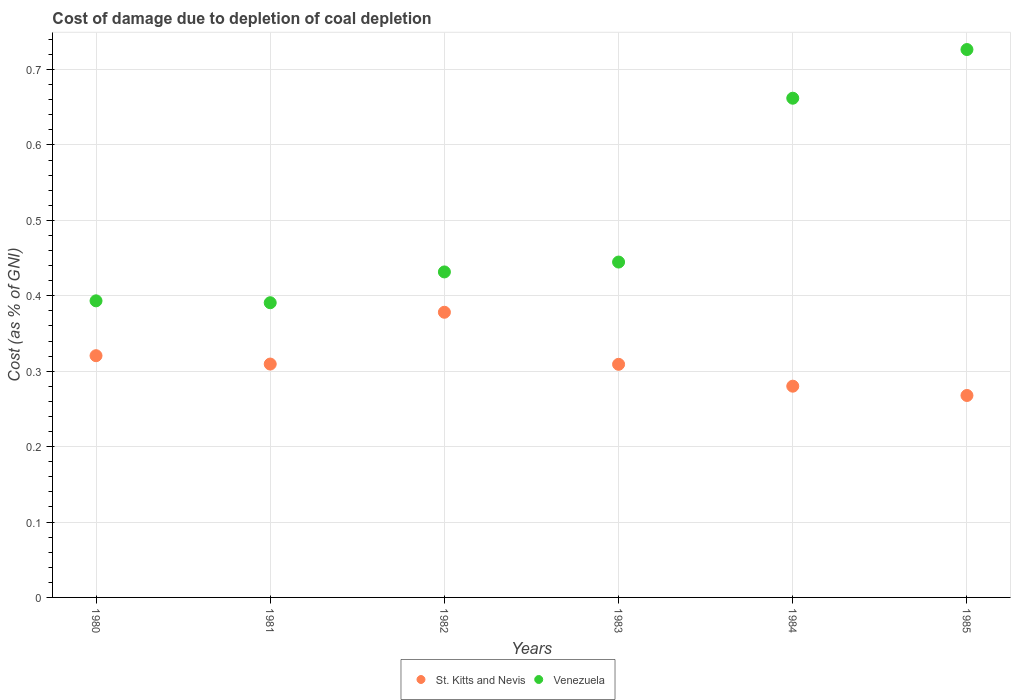What is the cost of damage caused due to coal depletion in St. Kitts and Nevis in 1981?
Your response must be concise. 0.31. Across all years, what is the maximum cost of damage caused due to coal depletion in St. Kitts and Nevis?
Make the answer very short. 0.38. Across all years, what is the minimum cost of damage caused due to coal depletion in Venezuela?
Provide a succinct answer. 0.39. In which year was the cost of damage caused due to coal depletion in St. Kitts and Nevis minimum?
Your answer should be very brief. 1985. What is the total cost of damage caused due to coal depletion in St. Kitts and Nevis in the graph?
Your answer should be compact. 1.87. What is the difference between the cost of damage caused due to coal depletion in St. Kitts and Nevis in 1981 and that in 1984?
Ensure brevity in your answer.  0.03. What is the difference between the cost of damage caused due to coal depletion in St. Kitts and Nevis in 1984 and the cost of damage caused due to coal depletion in Venezuela in 1982?
Keep it short and to the point. -0.15. What is the average cost of damage caused due to coal depletion in Venezuela per year?
Offer a very short reply. 0.51. In the year 1984, what is the difference between the cost of damage caused due to coal depletion in St. Kitts and Nevis and cost of damage caused due to coal depletion in Venezuela?
Keep it short and to the point. -0.38. What is the ratio of the cost of damage caused due to coal depletion in Venezuela in 1983 to that in 1985?
Provide a succinct answer. 0.61. What is the difference between the highest and the second highest cost of damage caused due to coal depletion in St. Kitts and Nevis?
Make the answer very short. 0.06. What is the difference between the highest and the lowest cost of damage caused due to coal depletion in St. Kitts and Nevis?
Your answer should be very brief. 0.11. In how many years, is the cost of damage caused due to coal depletion in St. Kitts and Nevis greater than the average cost of damage caused due to coal depletion in St. Kitts and Nevis taken over all years?
Provide a short and direct response. 2. Does the cost of damage caused due to coal depletion in Venezuela monotonically increase over the years?
Your answer should be very brief. No. Is the cost of damage caused due to coal depletion in Venezuela strictly greater than the cost of damage caused due to coal depletion in St. Kitts and Nevis over the years?
Your answer should be very brief. Yes. Is the cost of damage caused due to coal depletion in Venezuela strictly less than the cost of damage caused due to coal depletion in St. Kitts and Nevis over the years?
Make the answer very short. No. How many dotlines are there?
Ensure brevity in your answer.  2. How many years are there in the graph?
Offer a terse response. 6. Does the graph contain any zero values?
Keep it short and to the point. No. Does the graph contain grids?
Keep it short and to the point. Yes. Where does the legend appear in the graph?
Your response must be concise. Bottom center. How many legend labels are there?
Provide a short and direct response. 2. How are the legend labels stacked?
Your answer should be compact. Horizontal. What is the title of the graph?
Provide a succinct answer. Cost of damage due to depletion of coal depletion. Does "Cabo Verde" appear as one of the legend labels in the graph?
Your answer should be very brief. No. What is the label or title of the X-axis?
Your response must be concise. Years. What is the label or title of the Y-axis?
Offer a terse response. Cost (as % of GNI). What is the Cost (as % of GNI) in St. Kitts and Nevis in 1980?
Make the answer very short. 0.32. What is the Cost (as % of GNI) in Venezuela in 1980?
Your answer should be very brief. 0.39. What is the Cost (as % of GNI) in St. Kitts and Nevis in 1981?
Give a very brief answer. 0.31. What is the Cost (as % of GNI) of Venezuela in 1981?
Keep it short and to the point. 0.39. What is the Cost (as % of GNI) in St. Kitts and Nevis in 1982?
Make the answer very short. 0.38. What is the Cost (as % of GNI) in Venezuela in 1982?
Your answer should be very brief. 0.43. What is the Cost (as % of GNI) of St. Kitts and Nevis in 1983?
Provide a short and direct response. 0.31. What is the Cost (as % of GNI) of Venezuela in 1983?
Keep it short and to the point. 0.44. What is the Cost (as % of GNI) in St. Kitts and Nevis in 1984?
Ensure brevity in your answer.  0.28. What is the Cost (as % of GNI) of Venezuela in 1984?
Make the answer very short. 0.66. What is the Cost (as % of GNI) of St. Kitts and Nevis in 1985?
Your answer should be compact. 0.27. What is the Cost (as % of GNI) of Venezuela in 1985?
Make the answer very short. 0.73. Across all years, what is the maximum Cost (as % of GNI) of St. Kitts and Nevis?
Make the answer very short. 0.38. Across all years, what is the maximum Cost (as % of GNI) of Venezuela?
Ensure brevity in your answer.  0.73. Across all years, what is the minimum Cost (as % of GNI) in St. Kitts and Nevis?
Keep it short and to the point. 0.27. Across all years, what is the minimum Cost (as % of GNI) in Venezuela?
Your answer should be very brief. 0.39. What is the total Cost (as % of GNI) of St. Kitts and Nevis in the graph?
Keep it short and to the point. 1.87. What is the total Cost (as % of GNI) in Venezuela in the graph?
Give a very brief answer. 3.05. What is the difference between the Cost (as % of GNI) in St. Kitts and Nevis in 1980 and that in 1981?
Provide a short and direct response. 0.01. What is the difference between the Cost (as % of GNI) of Venezuela in 1980 and that in 1981?
Keep it short and to the point. 0. What is the difference between the Cost (as % of GNI) of St. Kitts and Nevis in 1980 and that in 1982?
Your answer should be compact. -0.06. What is the difference between the Cost (as % of GNI) in Venezuela in 1980 and that in 1982?
Make the answer very short. -0.04. What is the difference between the Cost (as % of GNI) in St. Kitts and Nevis in 1980 and that in 1983?
Offer a terse response. 0.01. What is the difference between the Cost (as % of GNI) of Venezuela in 1980 and that in 1983?
Make the answer very short. -0.05. What is the difference between the Cost (as % of GNI) of St. Kitts and Nevis in 1980 and that in 1984?
Your response must be concise. 0.04. What is the difference between the Cost (as % of GNI) in Venezuela in 1980 and that in 1984?
Keep it short and to the point. -0.27. What is the difference between the Cost (as % of GNI) of St. Kitts and Nevis in 1980 and that in 1985?
Give a very brief answer. 0.05. What is the difference between the Cost (as % of GNI) in Venezuela in 1980 and that in 1985?
Your response must be concise. -0.33. What is the difference between the Cost (as % of GNI) in St. Kitts and Nevis in 1981 and that in 1982?
Provide a succinct answer. -0.07. What is the difference between the Cost (as % of GNI) of Venezuela in 1981 and that in 1982?
Give a very brief answer. -0.04. What is the difference between the Cost (as % of GNI) in St. Kitts and Nevis in 1981 and that in 1983?
Give a very brief answer. 0. What is the difference between the Cost (as % of GNI) in Venezuela in 1981 and that in 1983?
Make the answer very short. -0.05. What is the difference between the Cost (as % of GNI) of St. Kitts and Nevis in 1981 and that in 1984?
Make the answer very short. 0.03. What is the difference between the Cost (as % of GNI) of Venezuela in 1981 and that in 1984?
Offer a terse response. -0.27. What is the difference between the Cost (as % of GNI) of St. Kitts and Nevis in 1981 and that in 1985?
Make the answer very short. 0.04. What is the difference between the Cost (as % of GNI) of Venezuela in 1981 and that in 1985?
Your response must be concise. -0.34. What is the difference between the Cost (as % of GNI) in St. Kitts and Nevis in 1982 and that in 1983?
Offer a terse response. 0.07. What is the difference between the Cost (as % of GNI) in Venezuela in 1982 and that in 1983?
Your answer should be compact. -0.01. What is the difference between the Cost (as % of GNI) of St. Kitts and Nevis in 1982 and that in 1984?
Your answer should be very brief. 0.1. What is the difference between the Cost (as % of GNI) of Venezuela in 1982 and that in 1984?
Your answer should be very brief. -0.23. What is the difference between the Cost (as % of GNI) of St. Kitts and Nevis in 1982 and that in 1985?
Ensure brevity in your answer.  0.11. What is the difference between the Cost (as % of GNI) of Venezuela in 1982 and that in 1985?
Keep it short and to the point. -0.29. What is the difference between the Cost (as % of GNI) of St. Kitts and Nevis in 1983 and that in 1984?
Your answer should be compact. 0.03. What is the difference between the Cost (as % of GNI) of Venezuela in 1983 and that in 1984?
Ensure brevity in your answer.  -0.22. What is the difference between the Cost (as % of GNI) of St. Kitts and Nevis in 1983 and that in 1985?
Keep it short and to the point. 0.04. What is the difference between the Cost (as % of GNI) in Venezuela in 1983 and that in 1985?
Offer a terse response. -0.28. What is the difference between the Cost (as % of GNI) of St. Kitts and Nevis in 1984 and that in 1985?
Offer a terse response. 0.01. What is the difference between the Cost (as % of GNI) of Venezuela in 1984 and that in 1985?
Your answer should be compact. -0.06. What is the difference between the Cost (as % of GNI) in St. Kitts and Nevis in 1980 and the Cost (as % of GNI) in Venezuela in 1981?
Give a very brief answer. -0.07. What is the difference between the Cost (as % of GNI) of St. Kitts and Nevis in 1980 and the Cost (as % of GNI) of Venezuela in 1982?
Offer a very short reply. -0.11. What is the difference between the Cost (as % of GNI) of St. Kitts and Nevis in 1980 and the Cost (as % of GNI) of Venezuela in 1983?
Provide a succinct answer. -0.12. What is the difference between the Cost (as % of GNI) in St. Kitts and Nevis in 1980 and the Cost (as % of GNI) in Venezuela in 1984?
Your answer should be compact. -0.34. What is the difference between the Cost (as % of GNI) in St. Kitts and Nevis in 1980 and the Cost (as % of GNI) in Venezuela in 1985?
Your response must be concise. -0.41. What is the difference between the Cost (as % of GNI) in St. Kitts and Nevis in 1981 and the Cost (as % of GNI) in Venezuela in 1982?
Offer a terse response. -0.12. What is the difference between the Cost (as % of GNI) of St. Kitts and Nevis in 1981 and the Cost (as % of GNI) of Venezuela in 1983?
Provide a short and direct response. -0.14. What is the difference between the Cost (as % of GNI) of St. Kitts and Nevis in 1981 and the Cost (as % of GNI) of Venezuela in 1984?
Offer a terse response. -0.35. What is the difference between the Cost (as % of GNI) in St. Kitts and Nevis in 1981 and the Cost (as % of GNI) in Venezuela in 1985?
Your answer should be very brief. -0.42. What is the difference between the Cost (as % of GNI) in St. Kitts and Nevis in 1982 and the Cost (as % of GNI) in Venezuela in 1983?
Ensure brevity in your answer.  -0.07. What is the difference between the Cost (as % of GNI) of St. Kitts and Nevis in 1982 and the Cost (as % of GNI) of Venezuela in 1984?
Offer a terse response. -0.28. What is the difference between the Cost (as % of GNI) of St. Kitts and Nevis in 1982 and the Cost (as % of GNI) of Venezuela in 1985?
Ensure brevity in your answer.  -0.35. What is the difference between the Cost (as % of GNI) in St. Kitts and Nevis in 1983 and the Cost (as % of GNI) in Venezuela in 1984?
Provide a succinct answer. -0.35. What is the difference between the Cost (as % of GNI) of St. Kitts and Nevis in 1983 and the Cost (as % of GNI) of Venezuela in 1985?
Offer a terse response. -0.42. What is the difference between the Cost (as % of GNI) of St. Kitts and Nevis in 1984 and the Cost (as % of GNI) of Venezuela in 1985?
Offer a terse response. -0.45. What is the average Cost (as % of GNI) of St. Kitts and Nevis per year?
Make the answer very short. 0.31. What is the average Cost (as % of GNI) in Venezuela per year?
Provide a succinct answer. 0.51. In the year 1980, what is the difference between the Cost (as % of GNI) of St. Kitts and Nevis and Cost (as % of GNI) of Venezuela?
Provide a succinct answer. -0.07. In the year 1981, what is the difference between the Cost (as % of GNI) in St. Kitts and Nevis and Cost (as % of GNI) in Venezuela?
Provide a short and direct response. -0.08. In the year 1982, what is the difference between the Cost (as % of GNI) in St. Kitts and Nevis and Cost (as % of GNI) in Venezuela?
Make the answer very short. -0.05. In the year 1983, what is the difference between the Cost (as % of GNI) of St. Kitts and Nevis and Cost (as % of GNI) of Venezuela?
Make the answer very short. -0.14. In the year 1984, what is the difference between the Cost (as % of GNI) in St. Kitts and Nevis and Cost (as % of GNI) in Venezuela?
Your answer should be compact. -0.38. In the year 1985, what is the difference between the Cost (as % of GNI) of St. Kitts and Nevis and Cost (as % of GNI) of Venezuela?
Offer a very short reply. -0.46. What is the ratio of the Cost (as % of GNI) of St. Kitts and Nevis in 1980 to that in 1981?
Provide a short and direct response. 1.04. What is the ratio of the Cost (as % of GNI) in Venezuela in 1980 to that in 1981?
Provide a short and direct response. 1.01. What is the ratio of the Cost (as % of GNI) in St. Kitts and Nevis in 1980 to that in 1982?
Offer a terse response. 0.85. What is the ratio of the Cost (as % of GNI) in Venezuela in 1980 to that in 1982?
Ensure brevity in your answer.  0.91. What is the ratio of the Cost (as % of GNI) of St. Kitts and Nevis in 1980 to that in 1983?
Your response must be concise. 1.04. What is the ratio of the Cost (as % of GNI) in Venezuela in 1980 to that in 1983?
Provide a succinct answer. 0.88. What is the ratio of the Cost (as % of GNI) of St. Kitts and Nevis in 1980 to that in 1984?
Ensure brevity in your answer.  1.14. What is the ratio of the Cost (as % of GNI) in Venezuela in 1980 to that in 1984?
Provide a short and direct response. 0.59. What is the ratio of the Cost (as % of GNI) of St. Kitts and Nevis in 1980 to that in 1985?
Provide a short and direct response. 1.2. What is the ratio of the Cost (as % of GNI) of Venezuela in 1980 to that in 1985?
Keep it short and to the point. 0.54. What is the ratio of the Cost (as % of GNI) of St. Kitts and Nevis in 1981 to that in 1982?
Your answer should be very brief. 0.82. What is the ratio of the Cost (as % of GNI) in Venezuela in 1981 to that in 1982?
Ensure brevity in your answer.  0.91. What is the ratio of the Cost (as % of GNI) of Venezuela in 1981 to that in 1983?
Give a very brief answer. 0.88. What is the ratio of the Cost (as % of GNI) of St. Kitts and Nevis in 1981 to that in 1984?
Your response must be concise. 1.1. What is the ratio of the Cost (as % of GNI) in Venezuela in 1981 to that in 1984?
Give a very brief answer. 0.59. What is the ratio of the Cost (as % of GNI) of St. Kitts and Nevis in 1981 to that in 1985?
Give a very brief answer. 1.16. What is the ratio of the Cost (as % of GNI) in Venezuela in 1981 to that in 1985?
Give a very brief answer. 0.54. What is the ratio of the Cost (as % of GNI) in St. Kitts and Nevis in 1982 to that in 1983?
Offer a very short reply. 1.22. What is the ratio of the Cost (as % of GNI) of Venezuela in 1982 to that in 1983?
Ensure brevity in your answer.  0.97. What is the ratio of the Cost (as % of GNI) in St. Kitts and Nevis in 1982 to that in 1984?
Offer a terse response. 1.35. What is the ratio of the Cost (as % of GNI) of Venezuela in 1982 to that in 1984?
Offer a terse response. 0.65. What is the ratio of the Cost (as % of GNI) of St. Kitts and Nevis in 1982 to that in 1985?
Your response must be concise. 1.41. What is the ratio of the Cost (as % of GNI) of Venezuela in 1982 to that in 1985?
Provide a succinct answer. 0.59. What is the ratio of the Cost (as % of GNI) of St. Kitts and Nevis in 1983 to that in 1984?
Ensure brevity in your answer.  1.1. What is the ratio of the Cost (as % of GNI) in Venezuela in 1983 to that in 1984?
Your answer should be very brief. 0.67. What is the ratio of the Cost (as % of GNI) of St. Kitts and Nevis in 1983 to that in 1985?
Offer a terse response. 1.15. What is the ratio of the Cost (as % of GNI) in Venezuela in 1983 to that in 1985?
Make the answer very short. 0.61. What is the ratio of the Cost (as % of GNI) of St. Kitts and Nevis in 1984 to that in 1985?
Your answer should be compact. 1.05. What is the ratio of the Cost (as % of GNI) in Venezuela in 1984 to that in 1985?
Make the answer very short. 0.91. What is the difference between the highest and the second highest Cost (as % of GNI) in St. Kitts and Nevis?
Provide a short and direct response. 0.06. What is the difference between the highest and the second highest Cost (as % of GNI) of Venezuela?
Provide a succinct answer. 0.06. What is the difference between the highest and the lowest Cost (as % of GNI) in St. Kitts and Nevis?
Ensure brevity in your answer.  0.11. What is the difference between the highest and the lowest Cost (as % of GNI) of Venezuela?
Provide a succinct answer. 0.34. 